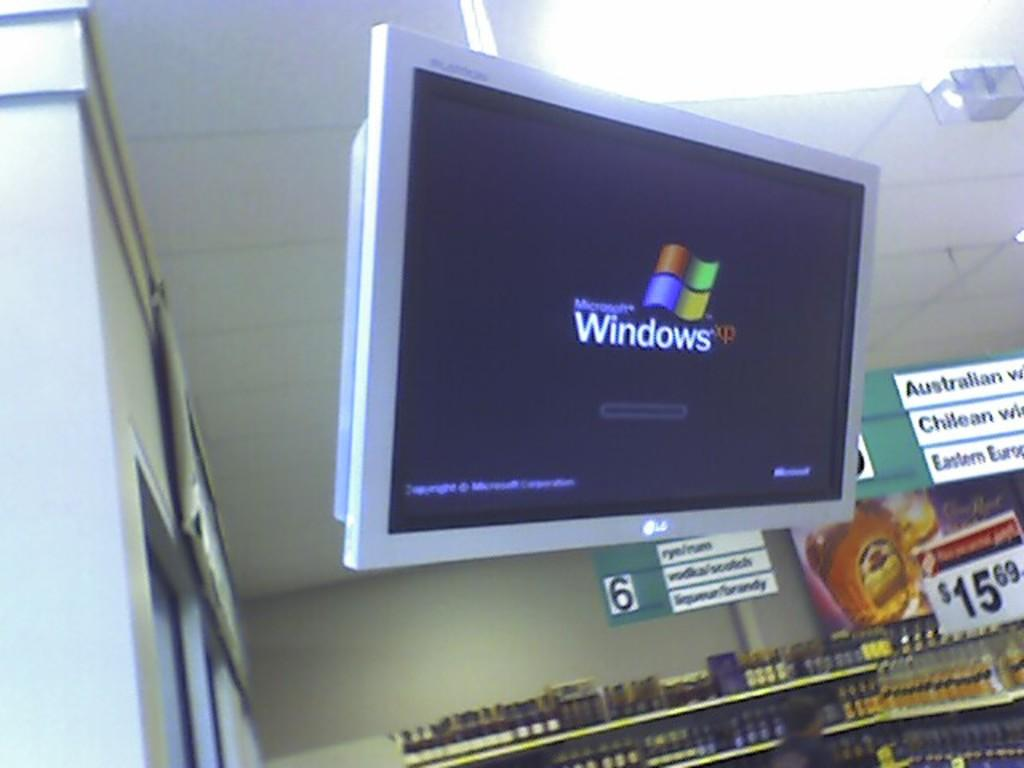<image>
Render a clear and concise summary of the photo. A monitor showing Microsoft Windows XP boot screen 